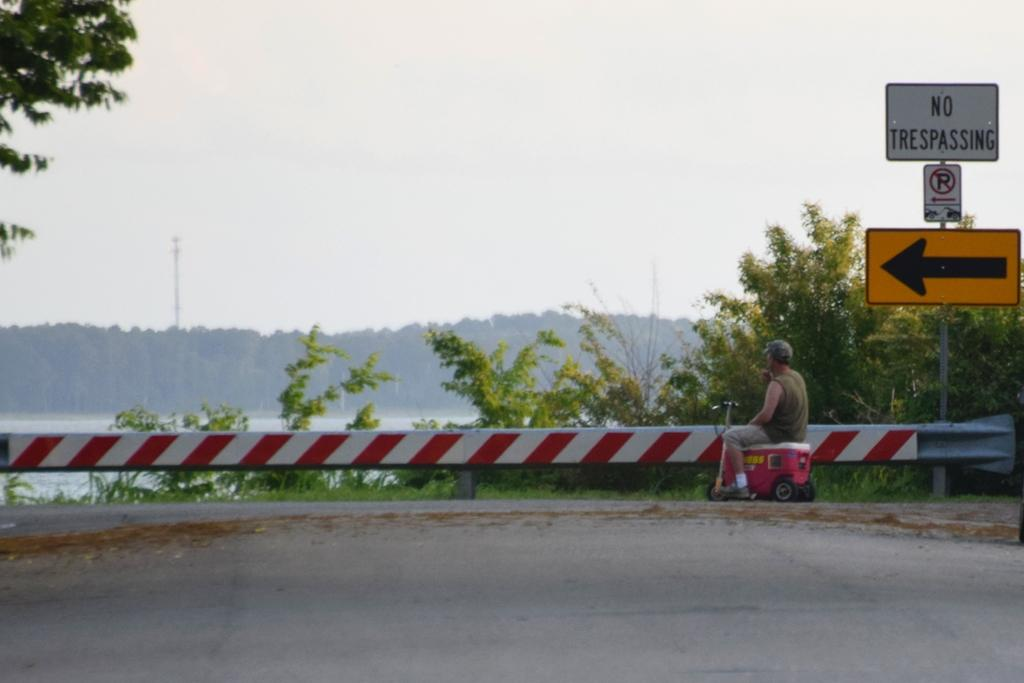What is in the foreground of the image? There is a road in the foreground of the image. What can be seen in the middle of the image? Trees, a person, railing, sign boards, a water body, and more trees are visible in the middle of the image. What is the person in the image doing? The person's activity cannot be determined from the provided facts. What is the purpose of the railing in the image? The purpose of the railing cannot be determined from the provided facts. What is the water body in the image? The water body is visible in the middle of the image, but its specific type or size cannot be determined from the provided facts. What is visible at the top of the image? The sky is visible at the top of the image. Where is the sink located in the image? There is no sink present in the image. What type of hose can be seen connected to the water body in the image? There is no hose present in the image. 